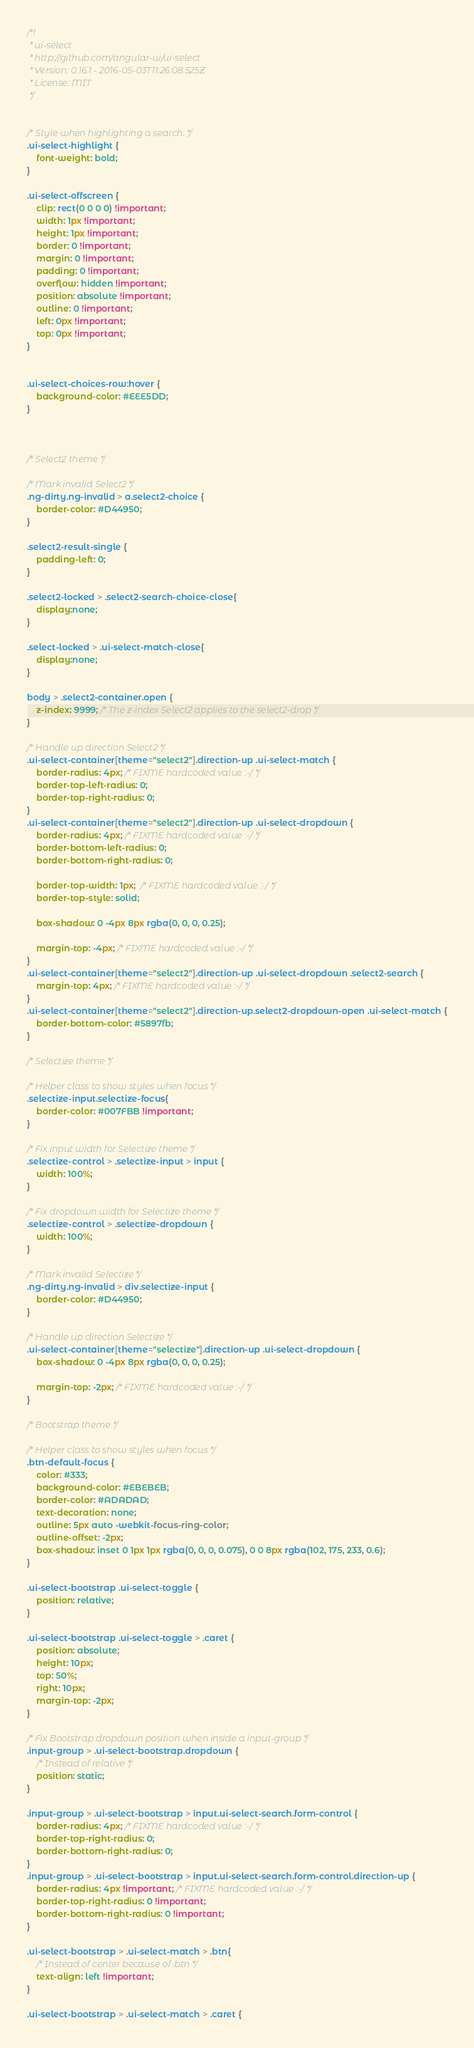<code> <loc_0><loc_0><loc_500><loc_500><_CSS_>/*!
 * ui-select
 * http://github.com/angular-ui/ui-select
 * Version: 0.16.1 - 2016-05-03T11:26:08.525Z
 * License: MIT
 */


/* Style when highlighting a search. */
.ui-select-highlight {
    font-weight: bold;
}

.ui-select-offscreen {
    clip: rect(0 0 0 0) !important;
    width: 1px !important;
    height: 1px !important;
    border: 0 !important;
    margin: 0 !important;
    padding: 0 !important;
    overflow: hidden !important;
    position: absolute !important;
    outline: 0 !important;
    left: 0px !important;
    top: 0px !important;
}


.ui-select-choices-row:hover {
    background-color: #EEE5DD;
}



/* Select2 theme */

/* Mark invalid Select2 */
.ng-dirty.ng-invalid > a.select2-choice {
    border-color: #D44950;
}

.select2-result-single {
    padding-left: 0;
}

.select2-locked > .select2-search-choice-close{
    display:none;
}

.select-locked > .ui-select-match-close{
    display:none;
}

body > .select2-container.open {
    z-index: 9999; /* The z-index Select2 applies to the select2-drop */
}

/* Handle up direction Select2 */
.ui-select-container[theme="select2"].direction-up .ui-select-match {
    border-radius: 4px; /* FIXME hardcoded value :-/ */
    border-top-left-radius: 0;
    border-top-right-radius: 0;
}
.ui-select-container[theme="select2"].direction-up .ui-select-dropdown {
    border-radius: 4px; /* FIXME hardcoded value :-/ */
    border-bottom-left-radius: 0;
    border-bottom-right-radius: 0;

    border-top-width: 1px;  /* FIXME hardcoded value :-/ */
    border-top-style: solid;

    box-shadow: 0 -4px 8px rgba(0, 0, 0, 0.25);

    margin-top: -4px; /* FIXME hardcoded value :-/ */
}
.ui-select-container[theme="select2"].direction-up .ui-select-dropdown .select2-search {
    margin-top: 4px; /* FIXME hardcoded value :-/ */
}
.ui-select-container[theme="select2"].direction-up.select2-dropdown-open .ui-select-match {
    border-bottom-color: #5897fb;
}

/* Selectize theme */

/* Helper class to show styles when focus */
.selectize-input.selectize-focus{
    border-color: #007FBB !important;
}

/* Fix input width for Selectize theme */
.selectize-control > .selectize-input > input {
    width: 100%;
}

/* Fix dropdown width for Selectize theme */
.selectize-control > .selectize-dropdown {
    width: 100%;
}

/* Mark invalid Selectize */
.ng-dirty.ng-invalid > div.selectize-input {
    border-color: #D44950;
}

/* Handle up direction Selectize */
.ui-select-container[theme="selectize"].direction-up .ui-select-dropdown {
    box-shadow: 0 -4px 8px rgba(0, 0, 0, 0.25);

    margin-top: -2px; /* FIXME hardcoded value :-/ */
}

/* Bootstrap theme */

/* Helper class to show styles when focus */
.btn-default-focus {
    color: #333;
    background-color: #EBEBEB;
    border-color: #ADADAD;
    text-decoration: none;
    outline: 5px auto -webkit-focus-ring-color;
    outline-offset: -2px;
    box-shadow: inset 0 1px 1px rgba(0, 0, 0, 0.075), 0 0 8px rgba(102, 175, 233, 0.6);
}

.ui-select-bootstrap .ui-select-toggle {
    position: relative;
}

.ui-select-bootstrap .ui-select-toggle > .caret {
    position: absolute;
    height: 10px;
    top: 50%;
    right: 10px;
    margin-top: -2px;
}

/* Fix Bootstrap dropdown position when inside a input-group */
.input-group > .ui-select-bootstrap.dropdown {
    /* Instead of relative */
    position: static;
}

.input-group > .ui-select-bootstrap > input.ui-select-search.form-control {
    border-radius: 4px; /* FIXME hardcoded value :-/ */
    border-top-right-radius: 0;
    border-bottom-right-radius: 0;
}
.input-group > .ui-select-bootstrap > input.ui-select-search.form-control.direction-up {
    border-radius: 4px !important; /* FIXME hardcoded value :-/ */
    border-top-right-radius: 0 !important;
    border-bottom-right-radius: 0 !important;
}

.ui-select-bootstrap > .ui-select-match > .btn{
    /* Instead of center because of .btn */
    text-align: left !important;
}

.ui-select-bootstrap > .ui-select-match > .caret {</code> 